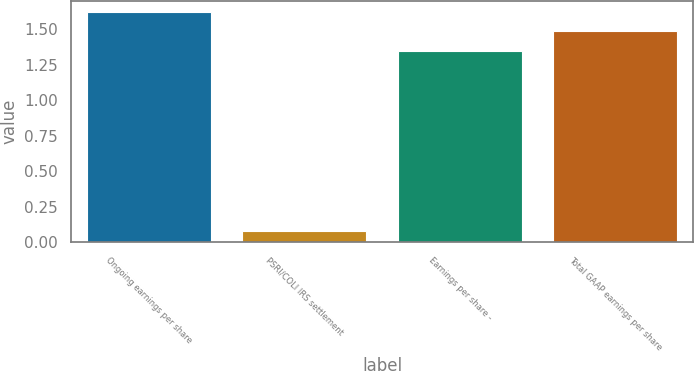Convert chart. <chart><loc_0><loc_0><loc_500><loc_500><bar_chart><fcel>Ongoing earnings per share<fcel>PSRI/COLI IRS settlement<fcel>Earnings per share -<fcel>Total GAAP earnings per share<nl><fcel>1.62<fcel>0.08<fcel>1.35<fcel>1.49<nl></chart> 